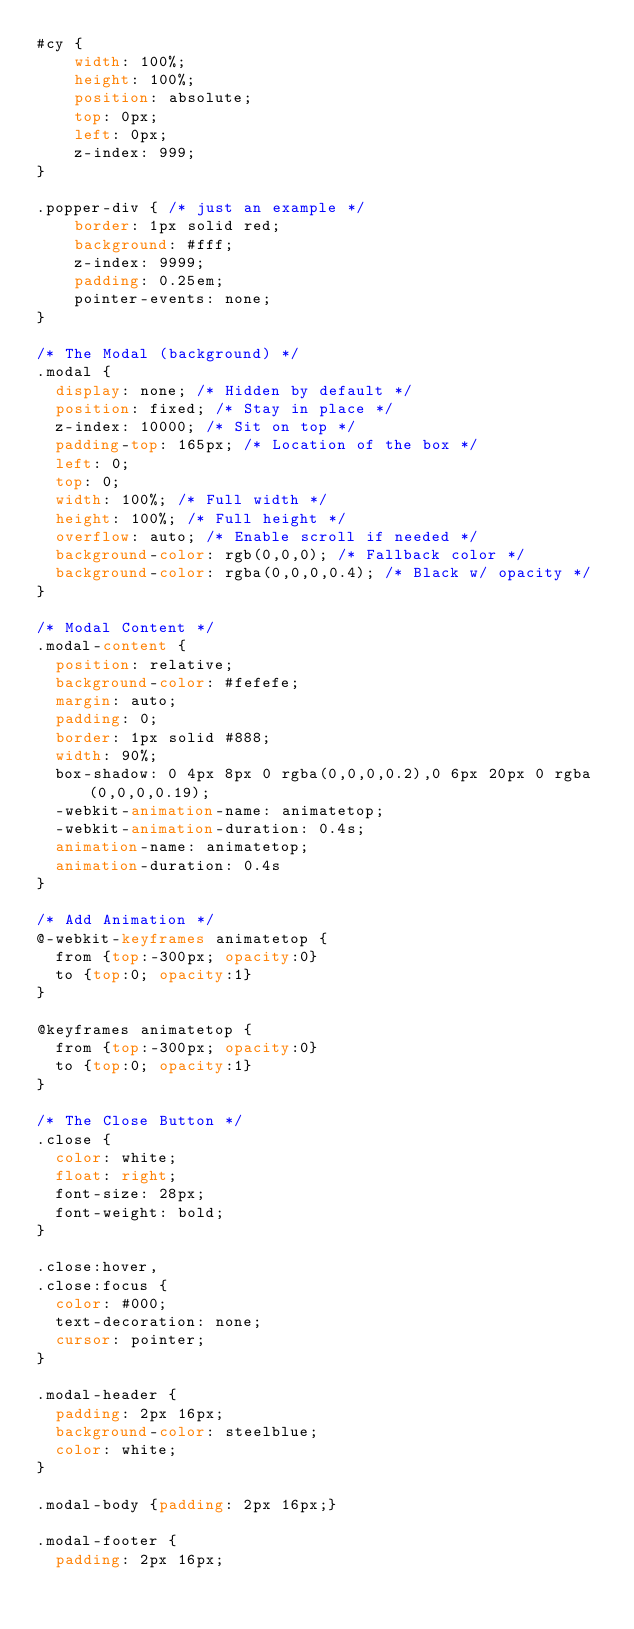Convert code to text. <code><loc_0><loc_0><loc_500><loc_500><_CSS_>#cy {
	width: 100%;
	height: 100%;
	position: absolute;
	top: 0px;
	left: 0px;
	z-index: 999;
}

.popper-div { /* just an example */
	border: 1px solid red;
	background: #fff;
	z-index: 9999;
	padding: 0.25em;
	pointer-events: none;
}

/* The Modal (background) */
.modal {
  display: none; /* Hidden by default */
  position: fixed; /* Stay in place */
  z-index: 10000; /* Sit on top */
  padding-top: 165px; /* Location of the box */
  left: 0;
  top: 0;
  width: 100%; /* Full width */
  height: 100%; /* Full height */
  overflow: auto; /* Enable scroll if needed */
  background-color: rgb(0,0,0); /* Fallback color */
  background-color: rgba(0,0,0,0.4); /* Black w/ opacity */
}

/* Modal Content */
.modal-content {
  position: relative;
  background-color: #fefefe;
  margin: auto;
  padding: 0;
  border: 1px solid #888;
  width: 90%;
  box-shadow: 0 4px 8px 0 rgba(0,0,0,0.2),0 6px 20px 0 rgba(0,0,0,0.19);
  -webkit-animation-name: animatetop;
  -webkit-animation-duration: 0.4s;
  animation-name: animatetop;
  animation-duration: 0.4s
}

/* Add Animation */
@-webkit-keyframes animatetop {
  from {top:-300px; opacity:0} 
  to {top:0; opacity:1}
}

@keyframes animatetop {
  from {top:-300px; opacity:0}
  to {top:0; opacity:1}
}

/* The Close Button */
.close {
  color: white;
  float: right;
  font-size: 28px;
  font-weight: bold;
}

.close:hover,
.close:focus {
  color: #000;
  text-decoration: none;
  cursor: pointer;
}

.modal-header {
  padding: 2px 16px;
  background-color: steelblue;
  color: white;
}

.modal-body {padding: 2px 16px;}

.modal-footer {
  padding: 2px 16px;</code> 